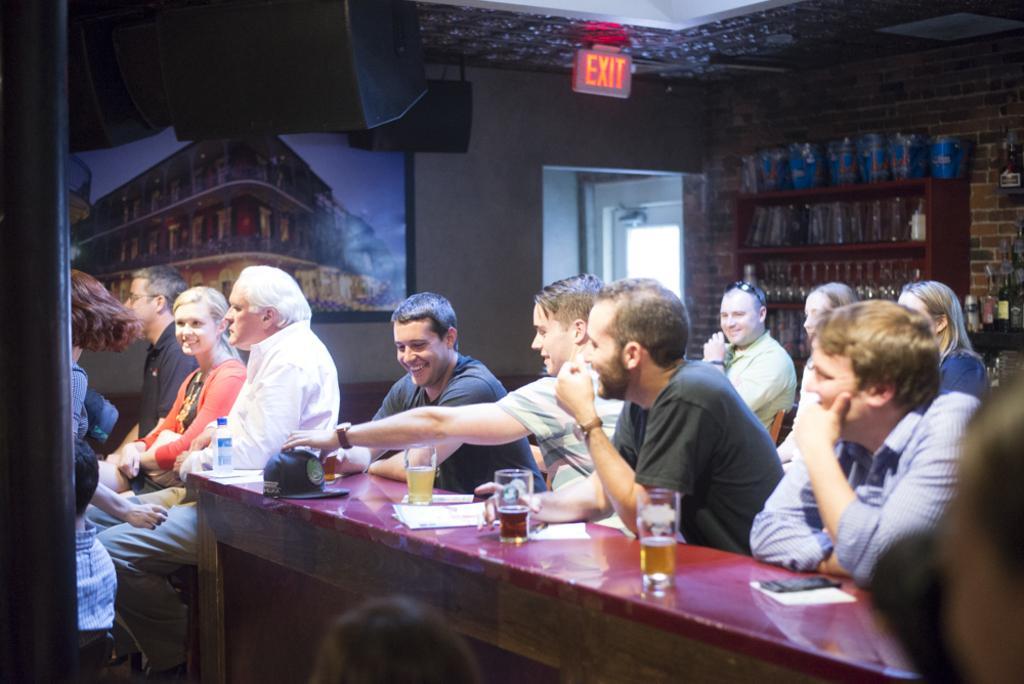Please provide a concise description of this image. In the image we can see there are lot of people who are sitting on chair and on table there are wine glass, paper and mobile phone. 